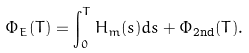Convert formula to latex. <formula><loc_0><loc_0><loc_500><loc_500>\Phi _ { E } ( T ) = \int _ { 0 } ^ { T } H _ { m } ( s ) d s + \Phi _ { \text {2nd} } ( T ) .</formula> 